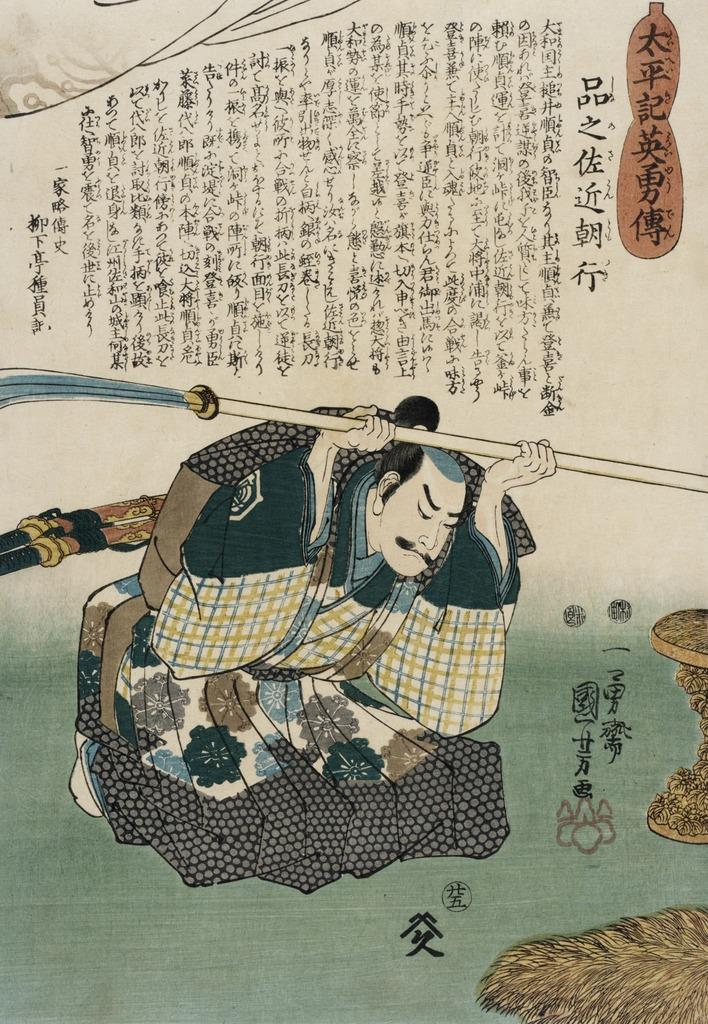What is depicted on the paper in the image? There is a picture of a person on a paper in the image. What else can be seen in the image besides the paper? There is some text at the top of the image. What type of dress is the person wearing in the image? There is no person wearing a dress in the image, as it is a picture of a person on a paper. 